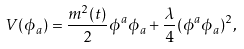<formula> <loc_0><loc_0><loc_500><loc_500>V ( \phi _ { a } ) = \frac { m ^ { 2 } ( t ) } { 2 } \phi ^ { a } \phi _ { a } + \frac { \lambda } { 4 } ( \phi ^ { a } \phi _ { a } ) ^ { 2 } ,</formula> 